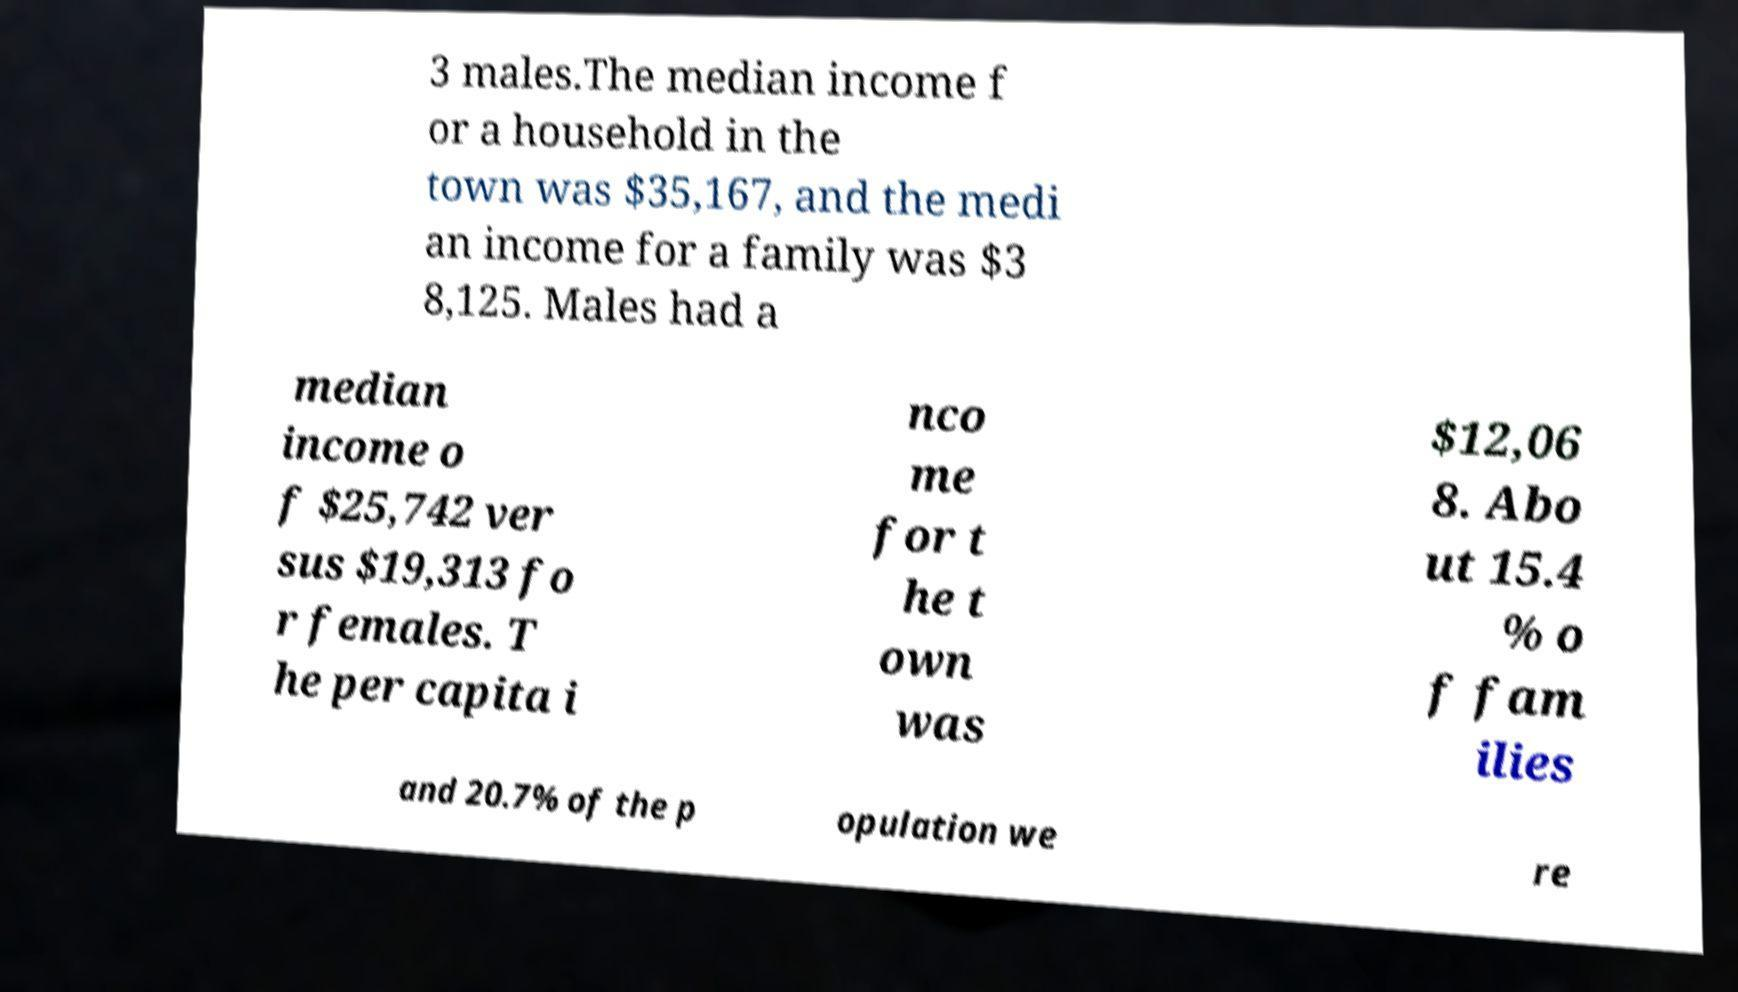Can you read and provide the text displayed in the image?This photo seems to have some interesting text. Can you extract and type it out for me? 3 males.The median income f or a household in the town was $35,167, and the medi an income for a family was $3 8,125. Males had a median income o f $25,742 ver sus $19,313 fo r females. T he per capita i nco me for t he t own was $12,06 8. Abo ut 15.4 % o f fam ilies and 20.7% of the p opulation we re 